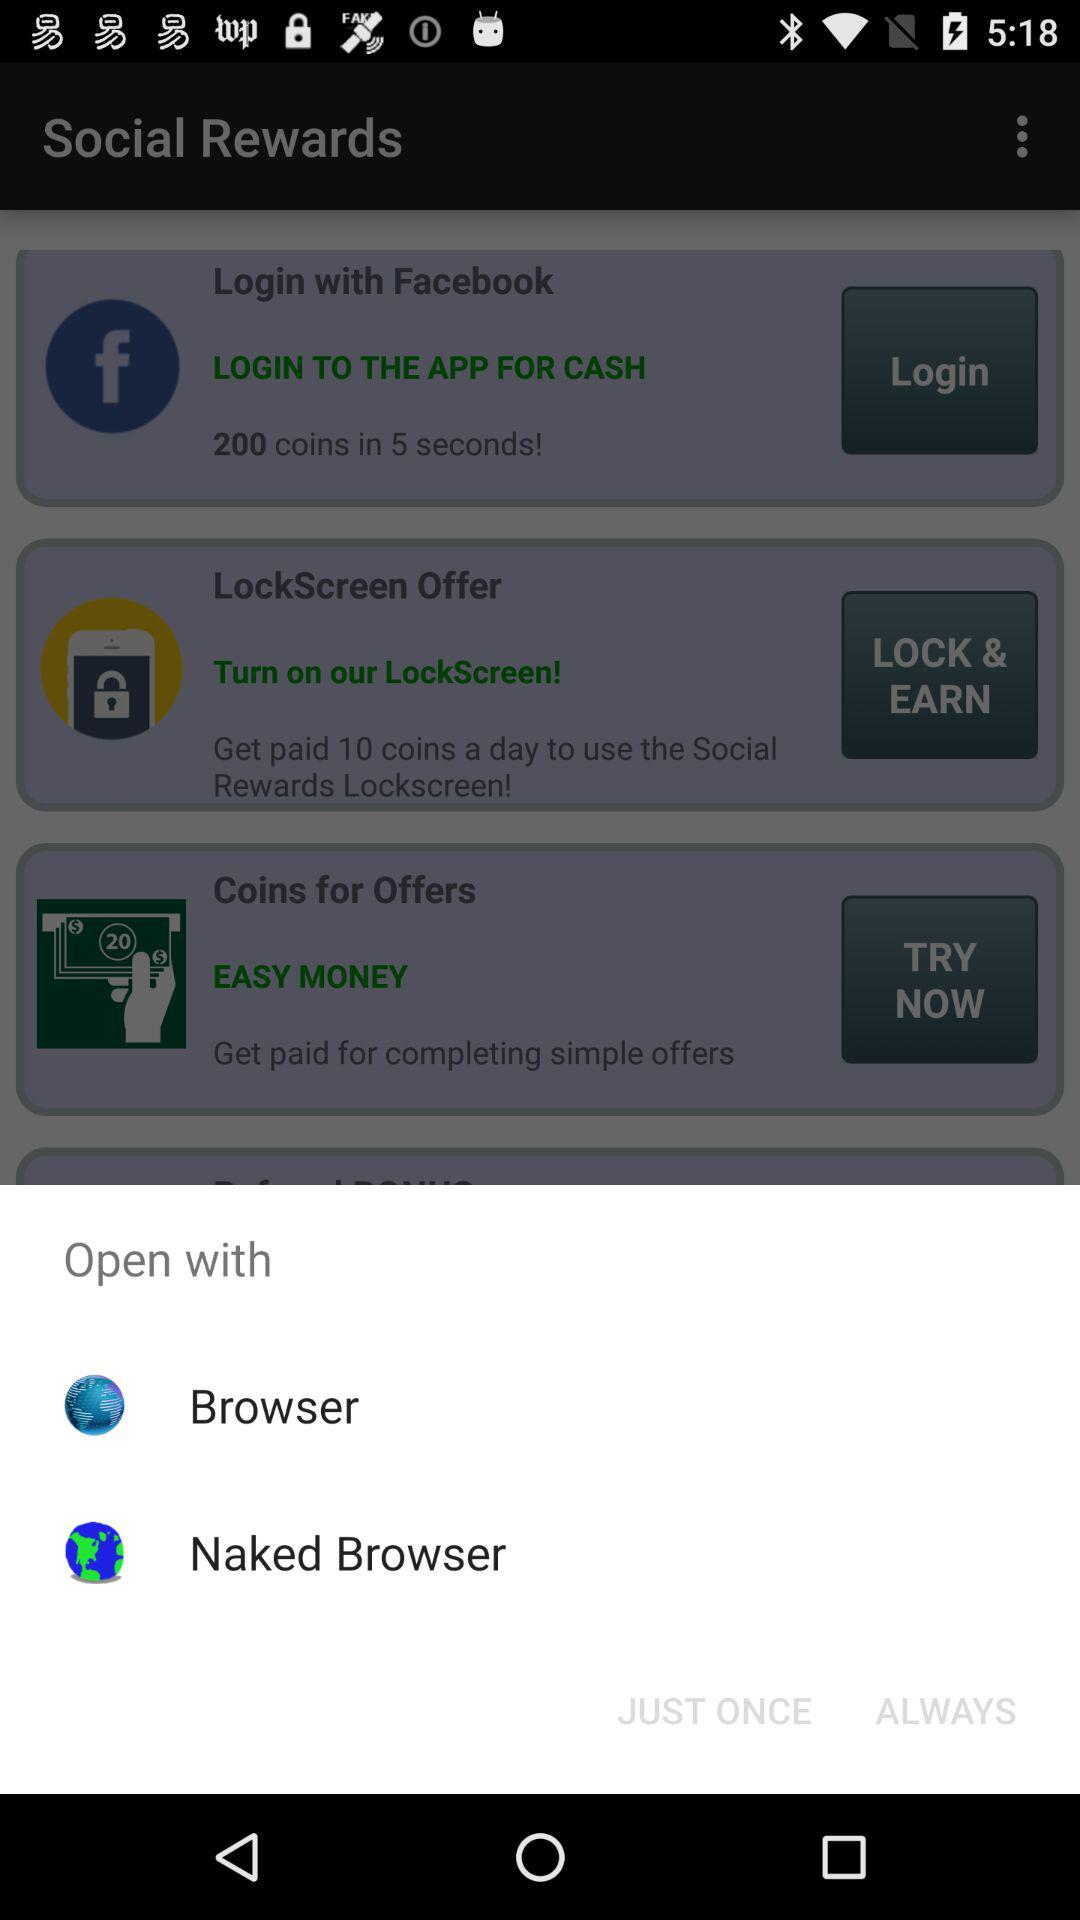How many offers are there on this page?
Answer the question using a single word or phrase. 3 